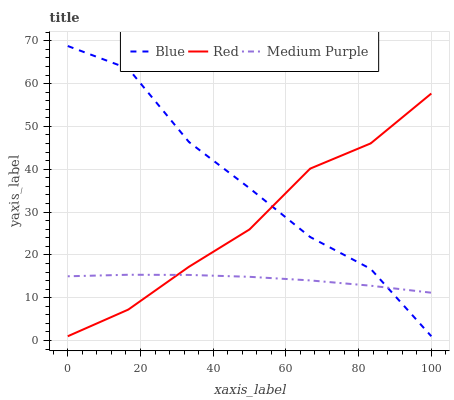Does Red have the minimum area under the curve?
Answer yes or no. No. Does Red have the maximum area under the curve?
Answer yes or no. No. Is Red the smoothest?
Answer yes or no. No. Is Red the roughest?
Answer yes or no. No. Does Medium Purple have the lowest value?
Answer yes or no. No. Does Red have the highest value?
Answer yes or no. No. 